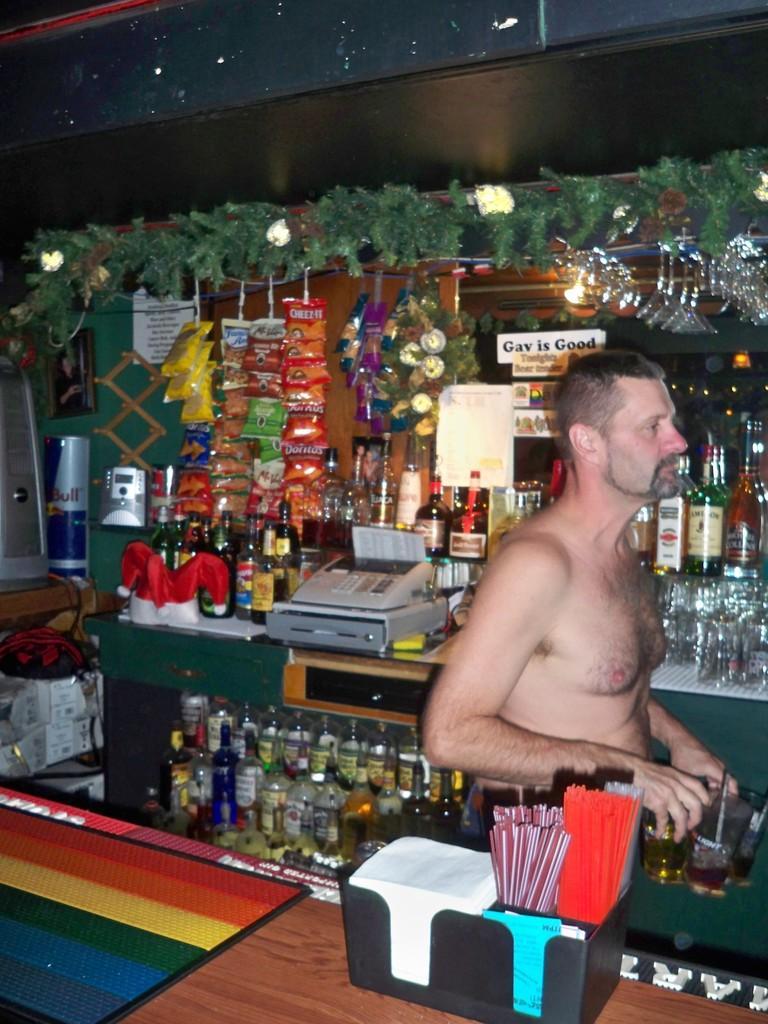Describe this image in one or two sentences. In this image there is a person standing behind the table having a tray which is having few papers and straws in it. Behind him there are few shelves having few bottles and machine on it. Few packets are hanged from the rod. Few glasses are hanged at the right side of the image. 